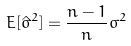<formula> <loc_0><loc_0><loc_500><loc_500>E [ \hat { \sigma } ^ { 2 } ] = \frac { n - 1 } { n } \sigma ^ { 2 }</formula> 